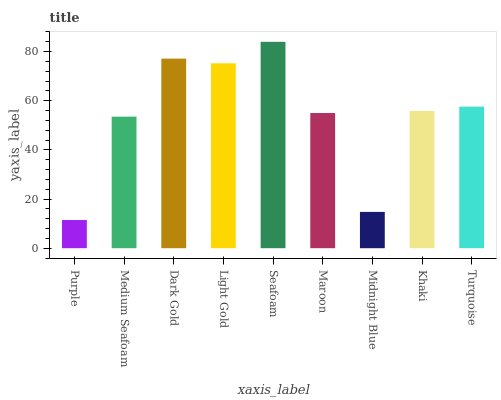Is Purple the minimum?
Answer yes or no. Yes. Is Seafoam the maximum?
Answer yes or no. Yes. Is Medium Seafoam the minimum?
Answer yes or no. No. Is Medium Seafoam the maximum?
Answer yes or no. No. Is Medium Seafoam greater than Purple?
Answer yes or no. Yes. Is Purple less than Medium Seafoam?
Answer yes or no. Yes. Is Purple greater than Medium Seafoam?
Answer yes or no. No. Is Medium Seafoam less than Purple?
Answer yes or no. No. Is Khaki the high median?
Answer yes or no. Yes. Is Khaki the low median?
Answer yes or no. Yes. Is Dark Gold the high median?
Answer yes or no. No. Is Midnight Blue the low median?
Answer yes or no. No. 